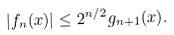<formula> <loc_0><loc_0><loc_500><loc_500>| f _ { n } ( x ) | \leq { 2 ^ { n / 2 } } g _ { n + 1 } ( x ) .</formula> 